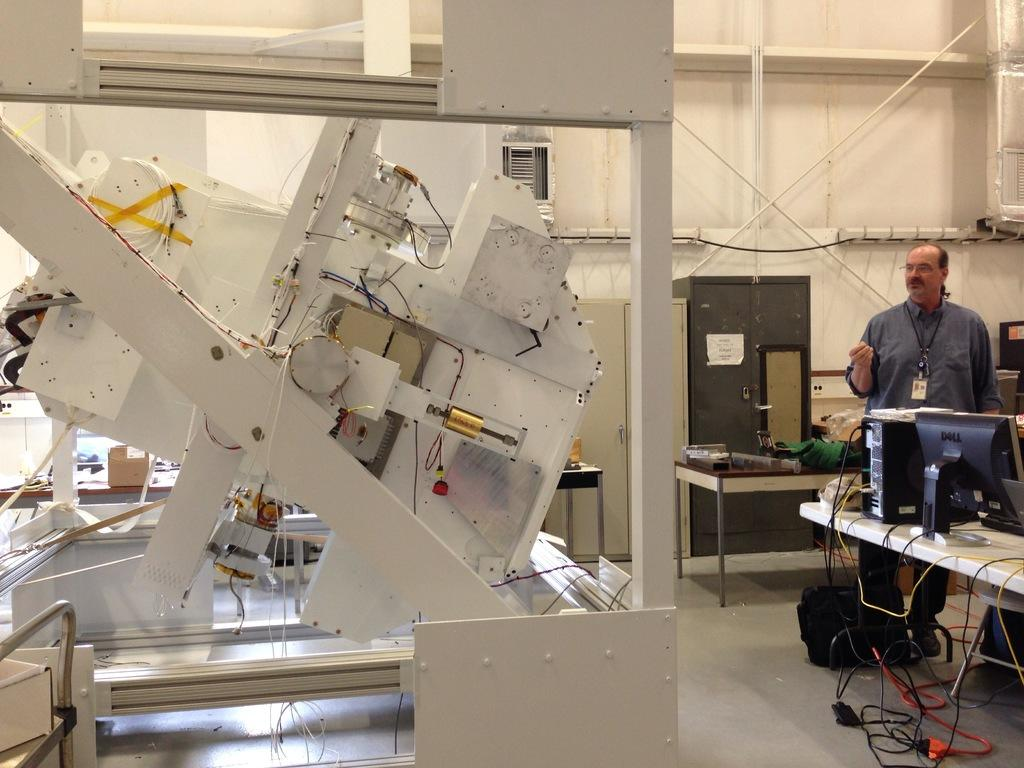What type of items can be seen in the image? There are electronic items in the image. What piece of furniture is present in the image? There is a table in the image. What electronic device is on the table? A monitor and a CPU are on the table. Can you describe the man in the background? The man in the background has a tag. What additional object can be seen in the background? There is an alamarah in the background. What type of hill can be seen in the image? There is no hill present in the image. Is there a yard visible in the image? There is no yard visible in the image. 